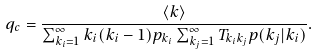Convert formula to latex. <formula><loc_0><loc_0><loc_500><loc_500>q _ { c } = \frac { \langle k \rangle } { \sum _ { k _ { i } = 1 } ^ { \infty } k _ { i } ( k _ { i } - 1 ) p _ { k _ { i } } \sum _ { k _ { j } = 1 } ^ { \infty } T _ { k _ { i } k _ { j } } p ( k _ { j } | k _ { i } ) } .</formula> 